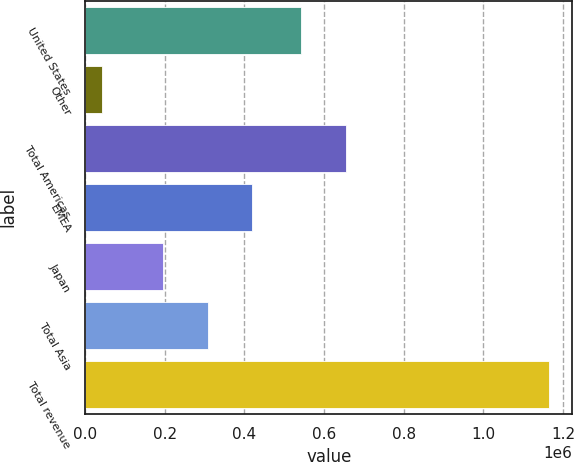Convert chart. <chart><loc_0><loc_0><loc_500><loc_500><bar_chart><fcel>United States<fcel>Other<fcel>Total Americas<fcel>EMEA<fcel>Japan<fcel>Total Asia<fcel>Total revenue<nl><fcel>541578<fcel>42176<fcel>653839<fcel>419979<fcel>195457<fcel>307718<fcel>1.16479e+06<nl></chart> 